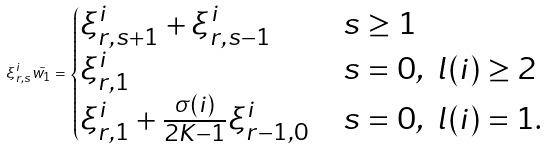Convert formula to latex. <formula><loc_0><loc_0><loc_500><loc_500>\xi ^ { i } _ { r , s } \tilde { w _ { 1 } } = \begin{cases} \xi ^ { i } _ { r , s + 1 } + \xi ^ { i } _ { r , s - 1 } & s \geq 1 \\ \xi ^ { i } _ { r , 1 } & s = 0 , \ l ( i ) \geq 2 \\ \xi ^ { i } _ { r , 1 } + \frac { \sigma ( i ) } { 2 K - 1 } \xi ^ { i } _ { r - 1 , 0 } & s = 0 , \ l ( i ) = 1 . \end{cases}</formula> 